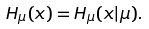<formula> <loc_0><loc_0><loc_500><loc_500>H _ { \mu } ( x ) = H _ { \mu } ( x | \mu ) .</formula> 